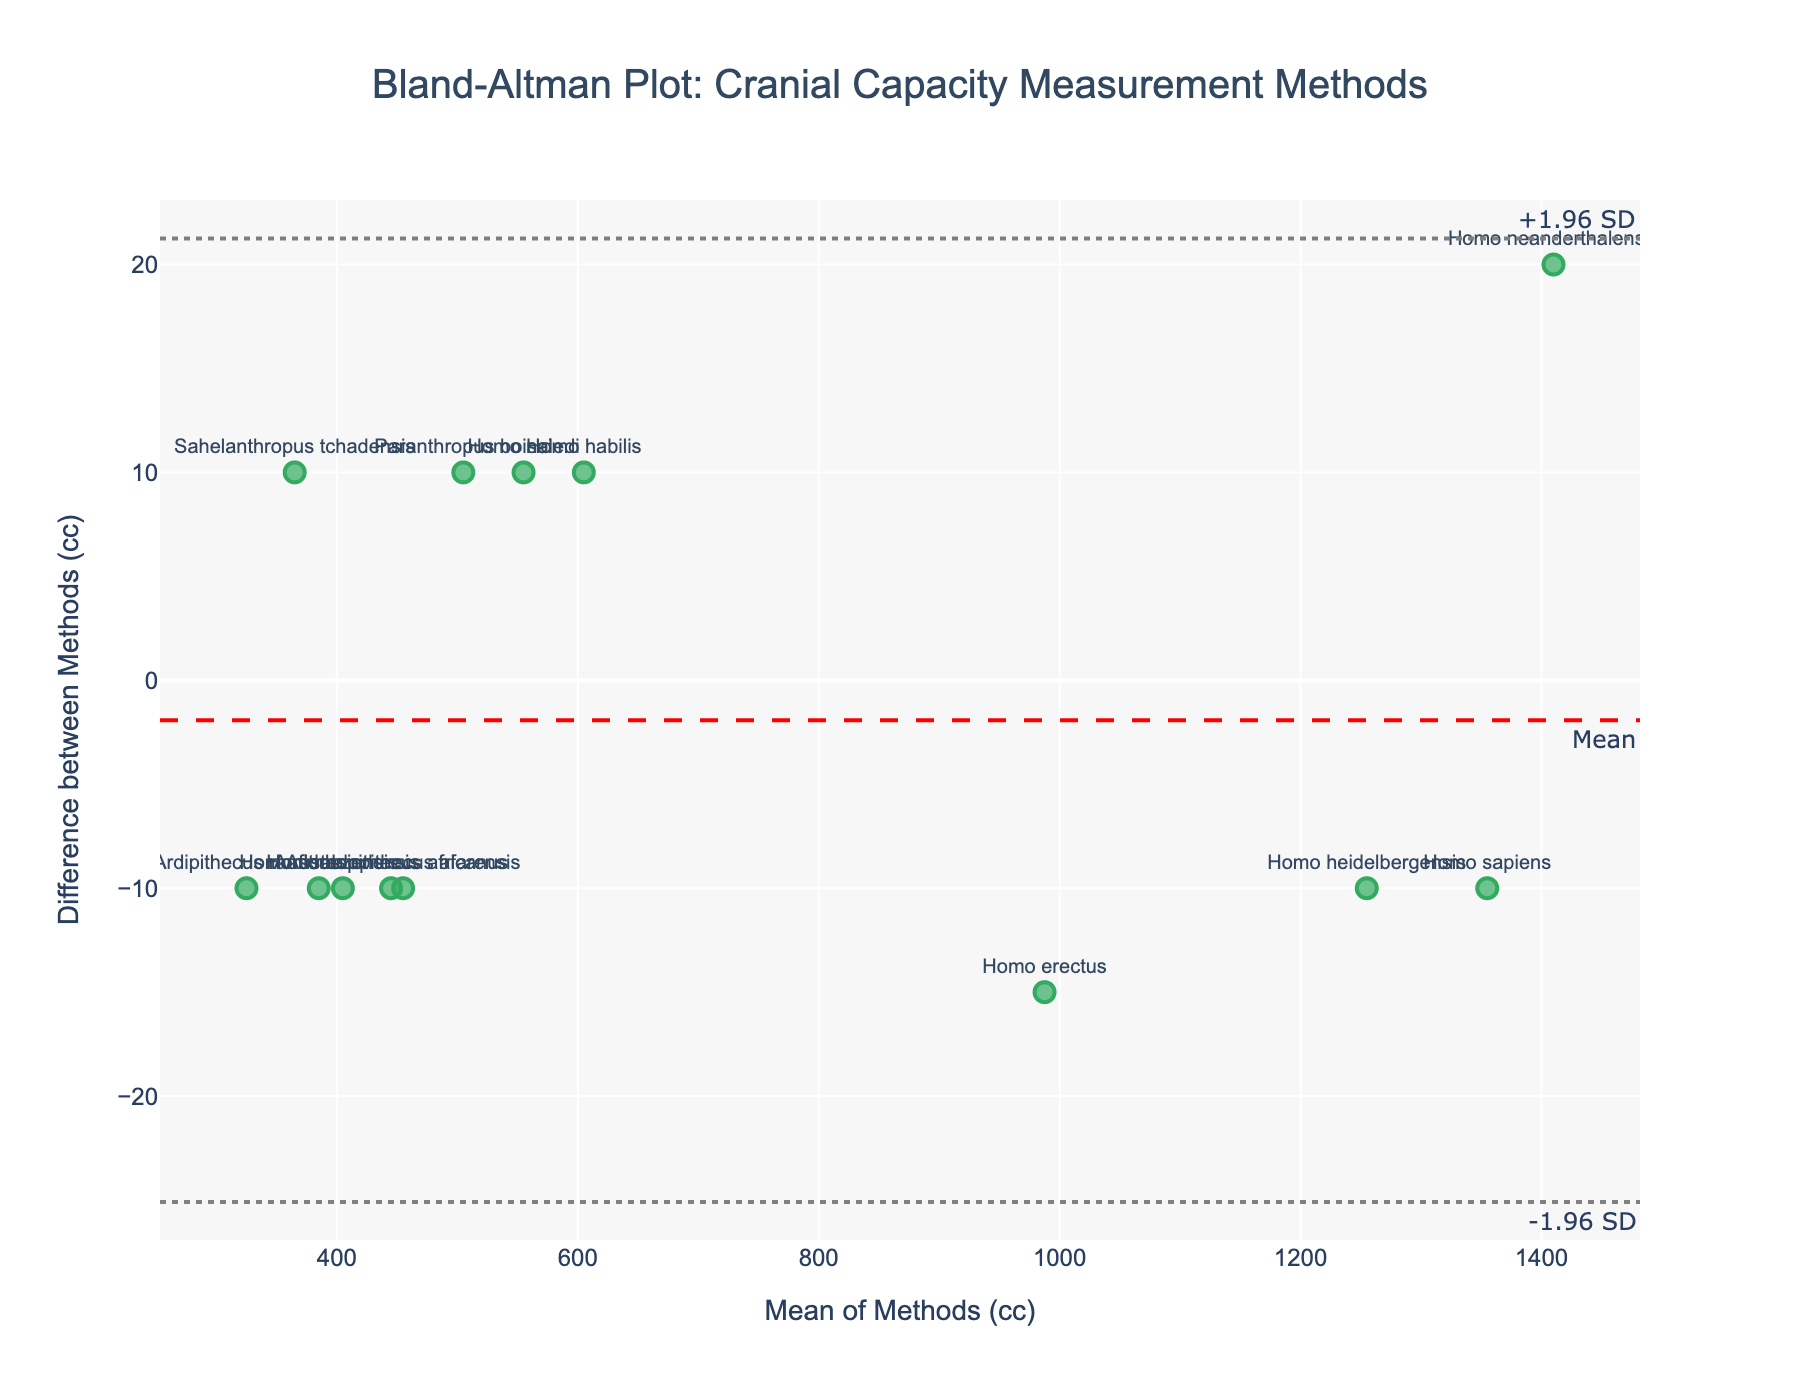What is the title of the plot? The title of the plot is shown at the top center and reads "Bland-Altman Plot: Cranial Capacity Measurement Methods".
Answer: Bland-Altman Plot: Cranial Capacity Measurement Methods How many hominid species are represented in the plot? Each data point corresponds to a hominid species, and there are 13 species in the dataset.
Answer: 13 What is the mean difference between the two measurement methods? The mean difference is represented by the horizontal dashed red line labeled "Mean".
Answer: Close to 0 Which species has the largest positive difference between Method 1 and Method 2? By examining the scatter points and reading the species labels, we see that Homo sapiens (1350, 1360) is the highest positive difference.
Answer: Homo sapiens What are the values of the limits of agreement (+1.96 SD and -1.96 SD)? The limits of agreement are indicated by the gray dotted lines. These can be read off the y-axis.
Answer: Approximately ±30 cc Is there a species for which the two methods provided identical measurements? If so, which one? We are looking for a data point that lies on the y=0 line. No data point appears to exactly lie on this line, so no species has identical measurements.
Answer: No Which two species have the smallest mean cranial capacity? The x-axis represents the mean cranial capacity. By looking at the left-most points on the plot, Ardipithecus ramidus (320, 330) and Sahelanthropus tchadensis (370, 360) have the smallest means.
Answer: Ardipithecus ramidus and Sahelanthropus tchadensis Which species has the smallest negative difference between Method 1 and Method 2? By examining the scatter points near the lowest position on the y-axis, Sahelanthropus tchadensis has the smallest negative difference.
Answer: Sahelanthropus tchadensis What is the mean cranial capacity of Australopithecus afarensis? To find the mean cranial capacity, we calculate the average of the two methods: (450 + 460) / 2.
Answer: 455 cc Which species have a difference of ±10 cc between the two methods? We look for points that are 10 units away from the y=0 line. Australopithecus afarensis, Homo habilis, and Homo naledi fit this criterion.
Answer: Australopithecus afarensis, Homo habilis, and Homo naledi 